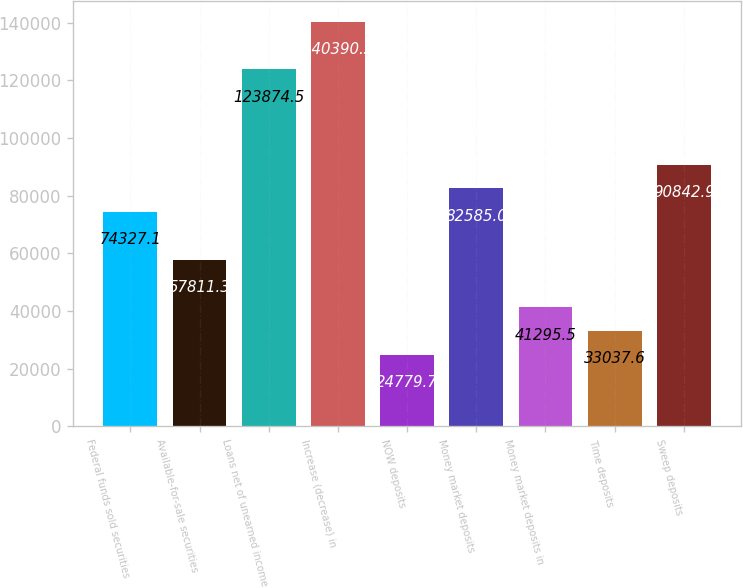Convert chart. <chart><loc_0><loc_0><loc_500><loc_500><bar_chart><fcel>Federal funds sold securities<fcel>Available-for-sale securities<fcel>Loans net of unearned income<fcel>Increase (decrease) in<fcel>NOW deposits<fcel>Money market deposits<fcel>Money market deposits in<fcel>Time deposits<fcel>Sweep deposits<nl><fcel>74327.1<fcel>57811.3<fcel>123874<fcel>140390<fcel>24779.7<fcel>82585<fcel>41295.5<fcel>33037.6<fcel>90842.9<nl></chart> 